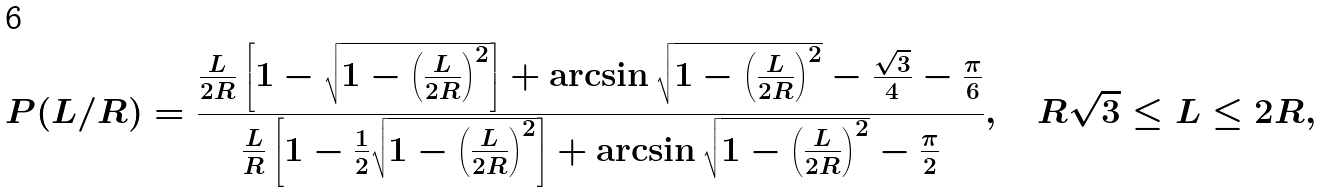<formula> <loc_0><loc_0><loc_500><loc_500>P ( L / R ) = \frac { \frac { L } { 2 R } \left [ 1 - \sqrt { 1 - \left ( \frac { L } { 2 R } \right ) ^ { 2 } } \right ] + \arcsin \sqrt { 1 - \left ( \frac { L } { 2 R } \right ) ^ { 2 } } - \frac { \sqrt { 3 } } { 4 } - \frac { \pi } { 6 } } { \frac { L } { R } \left [ 1 - \frac { 1 } { 2 } \sqrt { 1 - \left ( \frac { L } { 2 R } \right ) ^ { 2 } } \right ] + \arcsin \sqrt { 1 - \left ( \frac { L } { 2 R } \right ) ^ { 2 } } - \frac { \pi } { 2 } } , \quad R \sqrt { 3 } \leq L \leq 2 R ,</formula> 